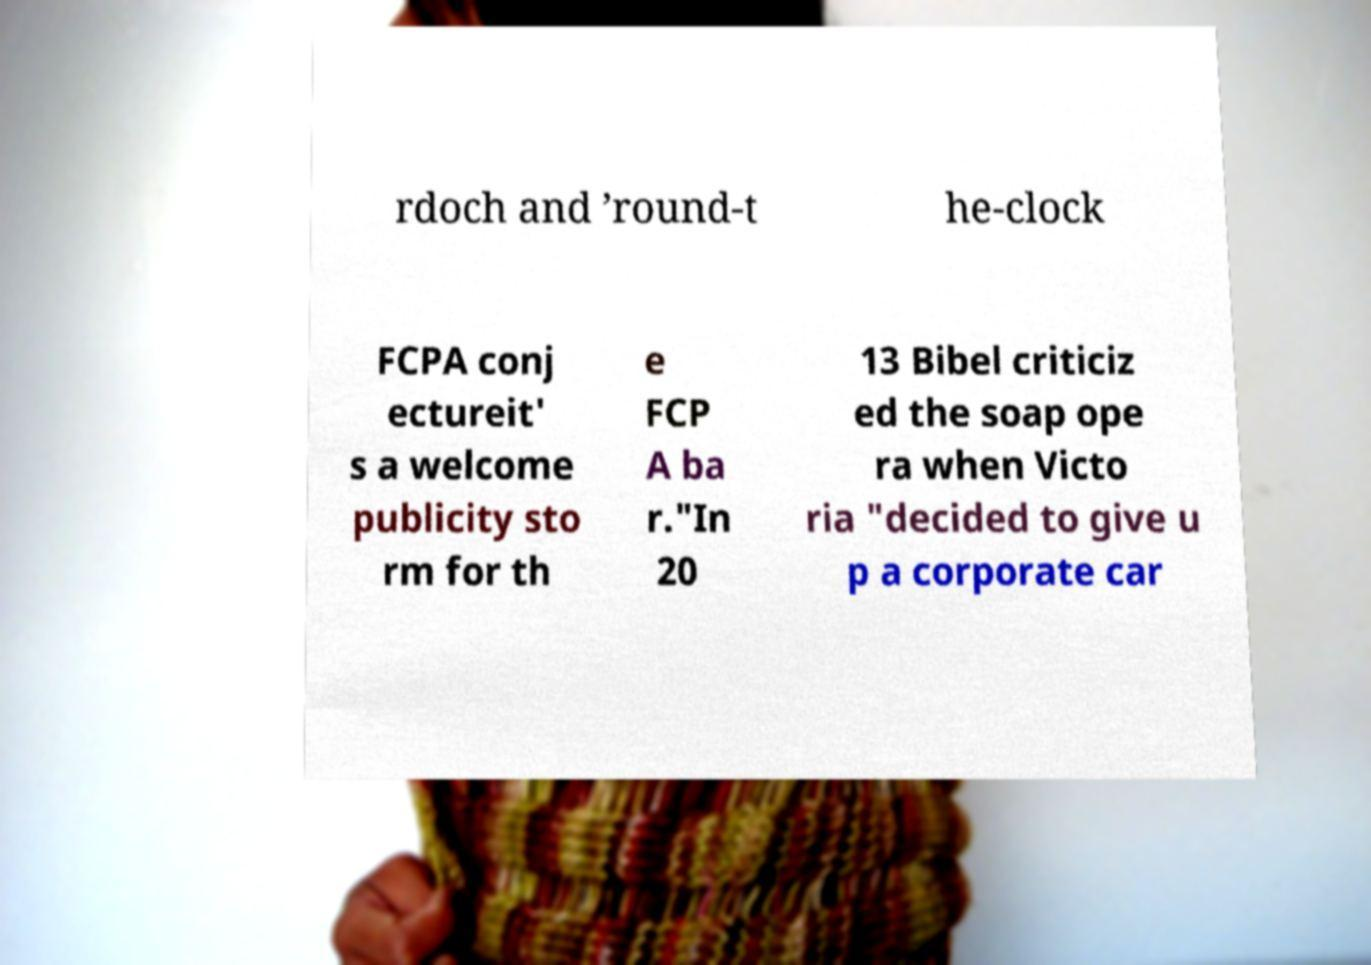Please read and relay the text visible in this image. What does it say? rdoch and ’round-t he-clock FCPA conj ectureit' s a welcome publicity sto rm for th e FCP A ba r."In 20 13 Bibel criticiz ed the soap ope ra when Victo ria "decided to give u p a corporate car 